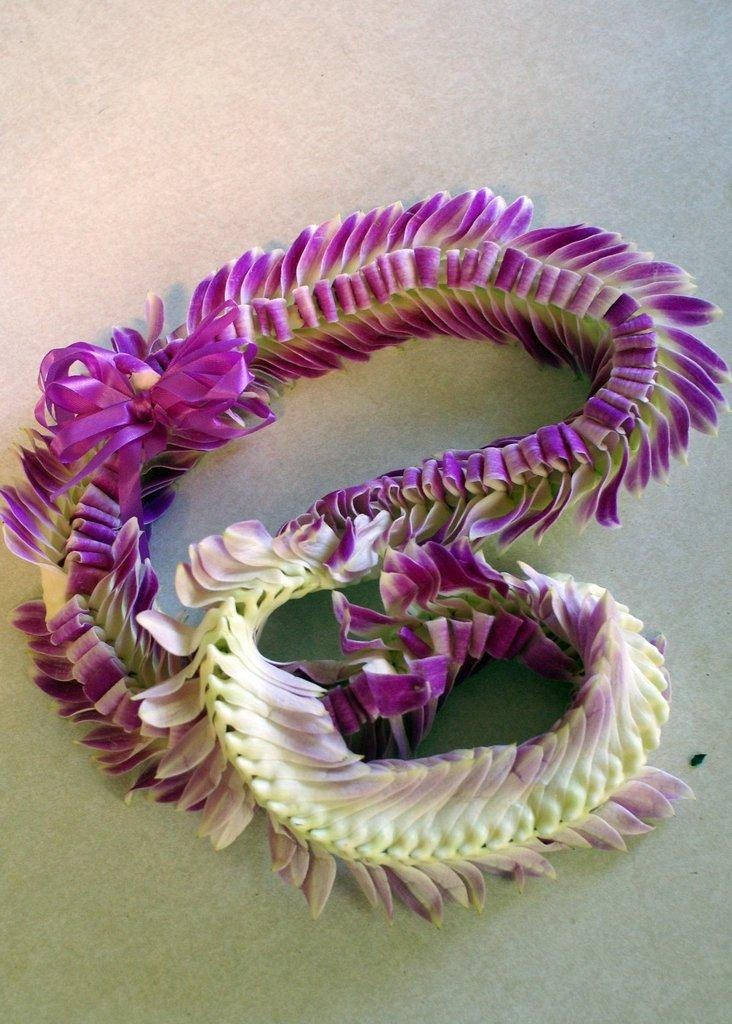What can be seen in the image? There is an object in the image. What colors are present on the object? The object has yellow and violet colors. What is the color of the surface on which the object is placed? The object is on a white surface. What is the position of the station in the image? There is no station present in the image. 